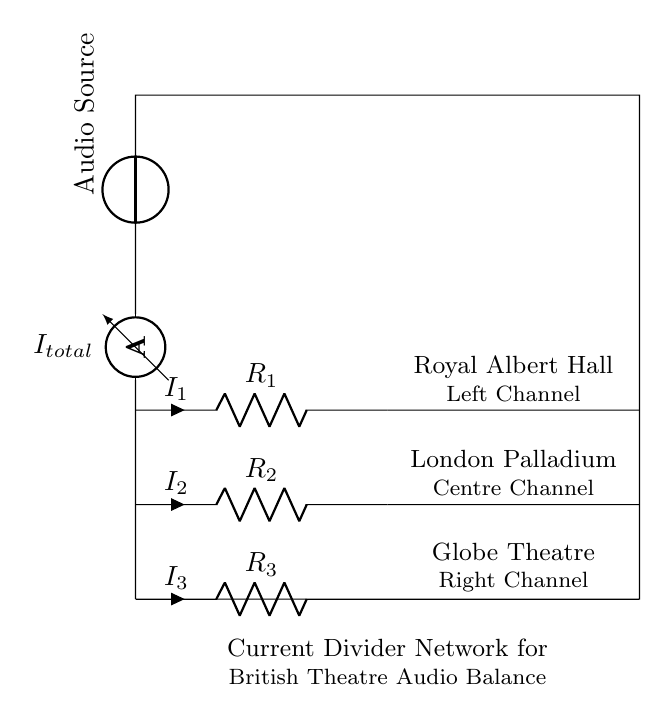What is the total current entering the circuit? The total current entering the circuit is represented by the ammeter symbol with the label I total. It indicates that the total amount of current from the audio source flows into the circuit before being divided among the resistors.
Answer: I total What is the resistance value of the left channel? The left channel is connected to resistor R one, which is labeled next to the resistor symbol. The value marked next to it identifies the precise resistance.
Answer: R one Which component is responsible for audio output? The audio source connected at the top of the circuit diagram supplies the input to the entire circuit. It sends audio signals that will be divided through the resistors to achieve proper channel output.
Answer: Audio Source How many channels are represented in the circuit? The circuit consists of three channels identified by the labels for their respective components and the nodes where the resistors are connected. Each resistor routes current to its designated channel.
Answer: Three How does the current divider work in balancing audio output? In a current divider, the incoming total current splits between multiple branches according to the resistance values. This means that different resistors will allow different amounts of current to flow through, thus balancing the audio output levels across the channels connected. Each channel receives a portion of the total current based on its resistance, allowing for an even audio experience.
Answer: Divides current based on resistance What does the notation R two signify in this circuit? R two represents one of the resistors in the current divider network. It is specifically the resistor connected to the centre channel, controlling how much current is allocated to that channel. The value next to it indicates its resistance in the circuit.
Answer: Resistor for Centre Channel 